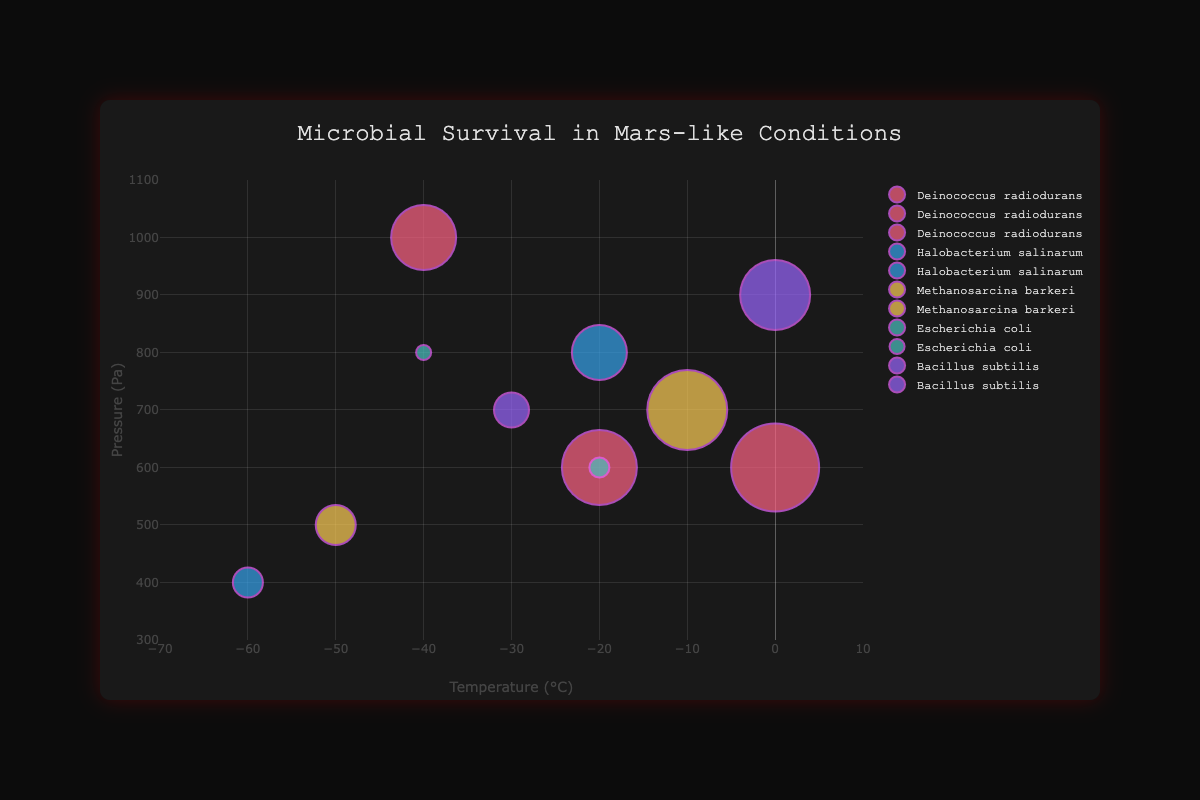What microbe has the highest survival rate at 0°C and 600 Pa? The chart shows a bubble for Deinococcus radiodurans at 0°C and 600 Pa with a size representing an 88% survival rate, the highest at these conditions
Answer: Deinococcus radiodurans Which microbe has the lowest survival rate at -40°C? The figure shows two microbes at -40°C: Deinococcus radiodurans at 1000 Pa with 65% survival rate and Escherichia coli at 800 Pa with 15%; thus, Escherichia coli has the lowest survival rate
Answer: Escherichia coli Which two microbes show survival rates at -20°C and 600 Pa, and which one survives better? The chart shows Deinococcus radiodurans and Escherichia coli at this condition, with bubble sizes of 75% and 20% respectively. Therefore, Deinococcus radiodurans survives better
Answer: Deinococcus radiodurans Comparing Deinococcus radiodurans and Bacillus subtilis, which one has a higher survival rate at 0°C? Bacillus subtilis at 0°C and 900 Pa shows a survival rate of 70%, while Deinococcus radiodurans at 0°C and 600 Pa shows 88%, making Deinococcus radiodurans higher
Answer: Deinococcus radiodurans What is the highest survival rate for Methanosarcina barkeri and under what conditions does it occur? The chart indicates Methanosarcina barkeri at -10°C and 700 Pa with a survival rate of 80%, which is the highest for this microbe
Answer: -10°C and 700 Pa Which microbe has the widest range of survival rates across different conditions? Observing the bubble sizes, Deinococcus radiodurans shows the highest variability: 65% at -40°C and 1000 Pa, 75% at -20°C and 600 Pa, and 88% at 0°C and 600 Pa
Answer: Deinococcus radiodurans What's the average survival rate of Bacillus subtilis across the given conditions? Bacillus subtilis has survival rates of 35% (-30°C and 700 Pa) and 70% (0°C and 900 Pa). The average is (35 + 70) / 2 = 52.5%
Answer: 52.5% Under what conditions does Halobacterium salinarum exhibit a survival rate of 30%? The chart shows at -60°C and 400 Pa, Halobacterium salinarum achieves a survival rate of 30% as indicated by the bubble size
Answer: -60°C and 400 Pa Which survival rate is observed for Escherichia coli at the highest pressure condition it was tested under? At 800 Pa and -40°C, the bubble size represents a survival rate of 15% for Escherichia coli, indicating this value at the highest pressure it was tested
Answer: 15% What temperature range does Deinococcus radiodurans exhibit survival rates over 70%? Examining the chart shows survival rates of 75% at -20°C, 88% at 0°C, and the lowest survival rate observed for it is 65% at -40°C. Thus, the temperature range above 70% spans -20°C to 0°C
Answer: -20°C to 0°C 